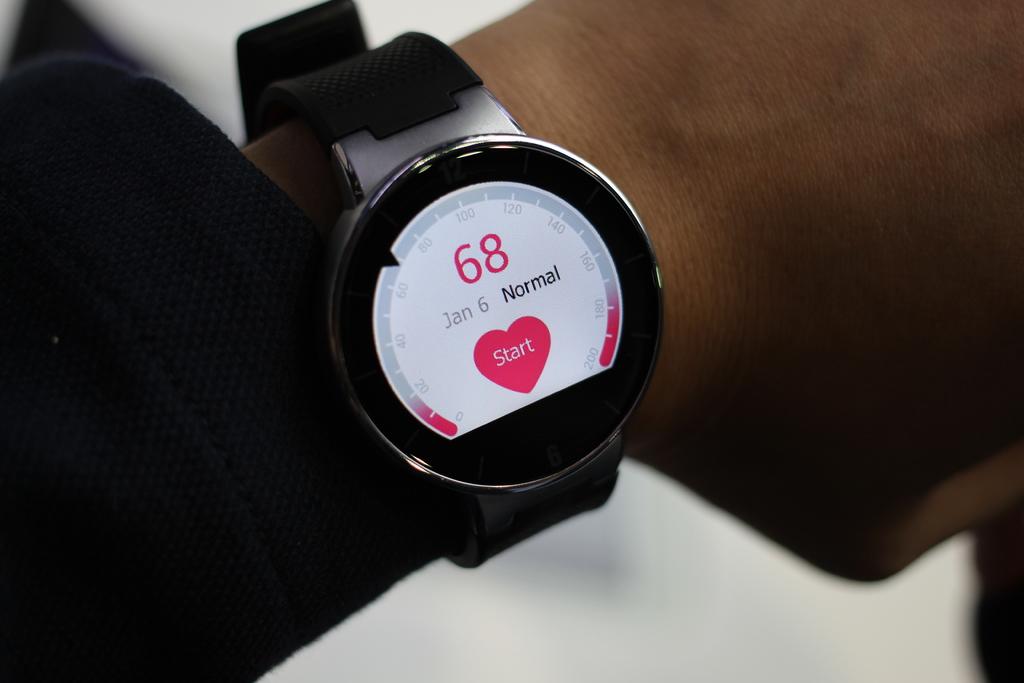What is the date on this watch?
Offer a very short reply. January 6. What is written in the heart on the watch?
Your answer should be very brief. Start. 